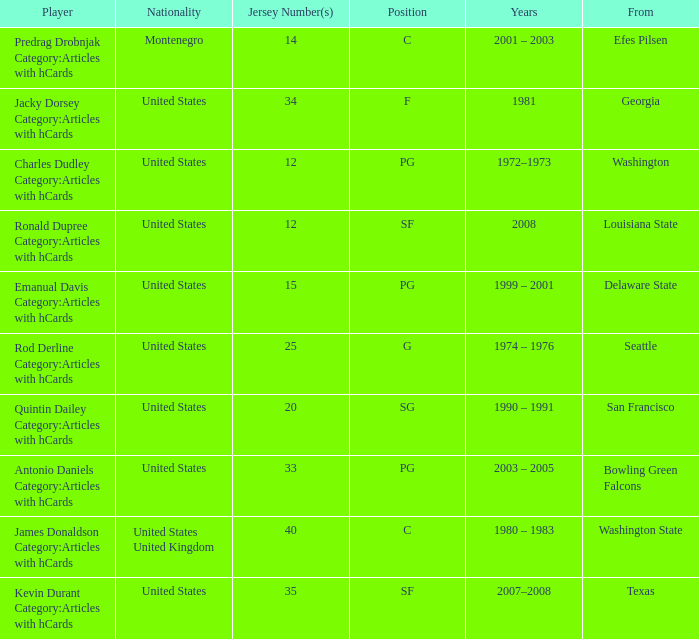What years featured the united states competitor with a 25 jersey number who studied at delaware state? 1999 – 2001. 